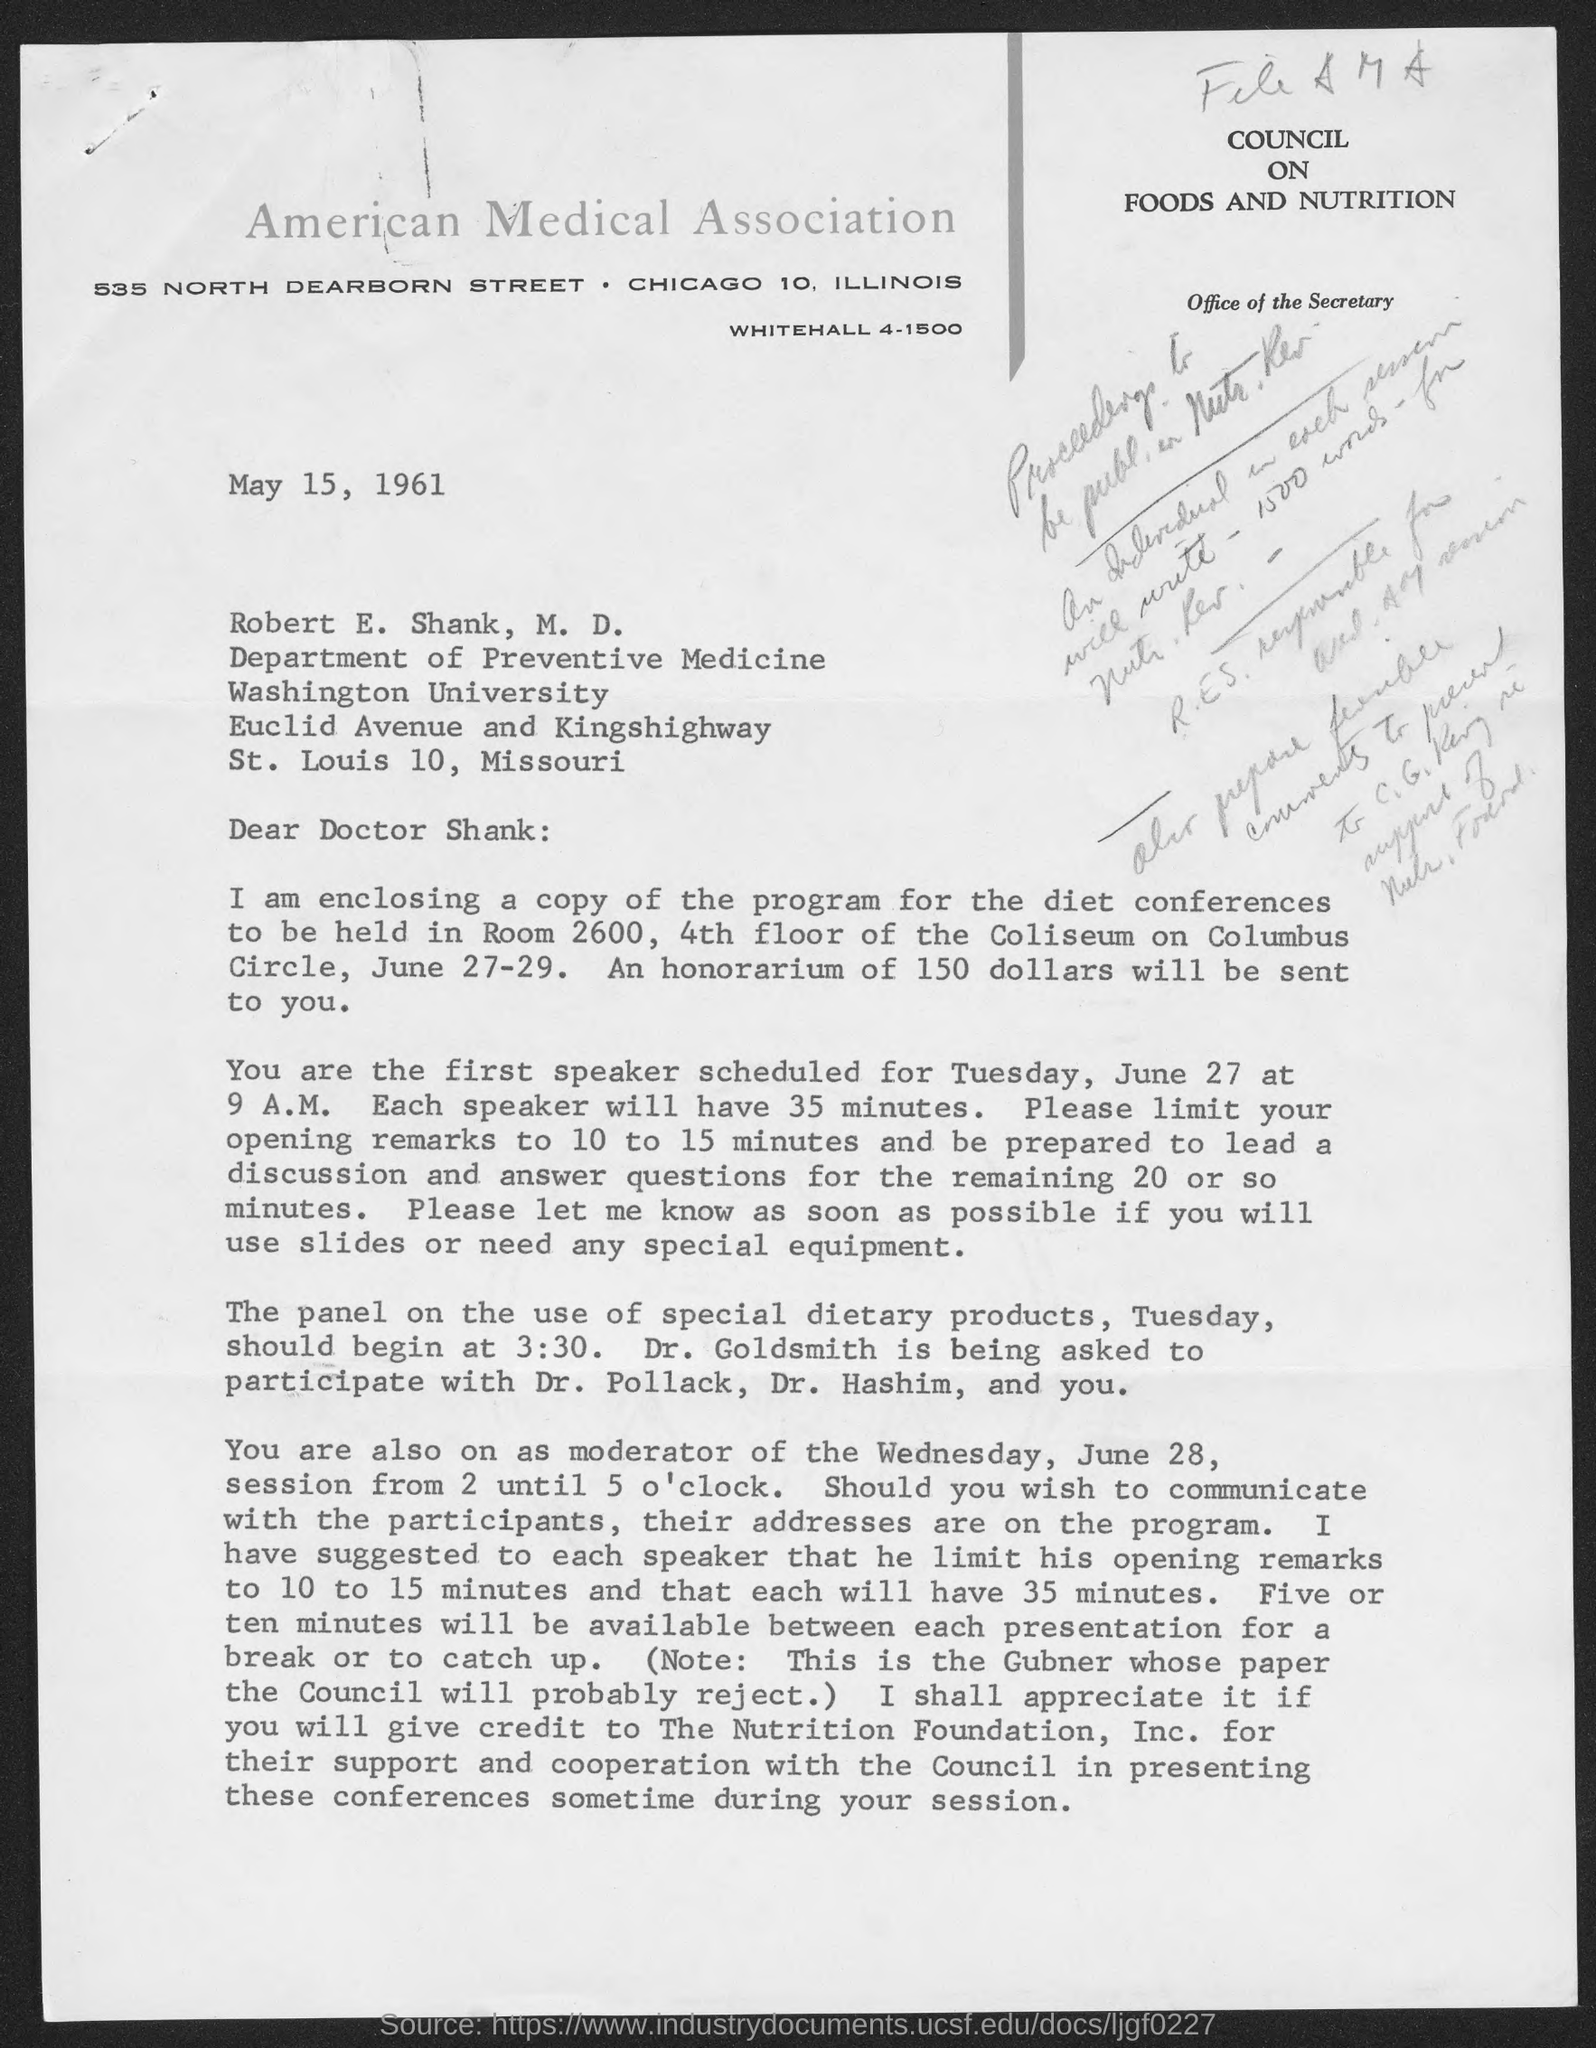What is the date on the document?
Offer a terse response. May 15, 1961. When is the diet conference held?
Keep it short and to the point. June 27-29. How much time each speaker will have?
Keep it short and to the point. 35 minutes. What is the honorarium that will be sent?
Provide a succinct answer. 150 dollars. How much should a speaker limit his opening remarks?
Provide a succinct answer. 10 to 15 minutes. How much time will be there for a break?
Provide a short and direct response. Five or ten minutes. 